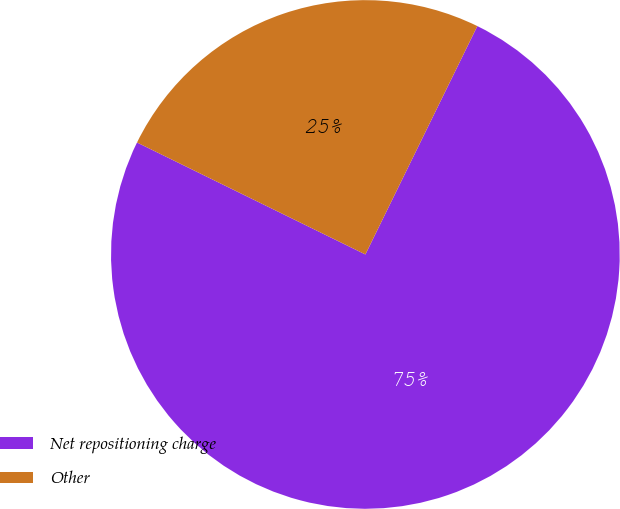<chart> <loc_0><loc_0><loc_500><loc_500><pie_chart><fcel>Net repositioning charge<fcel>Other<nl><fcel>75.0%<fcel>25.0%<nl></chart> 